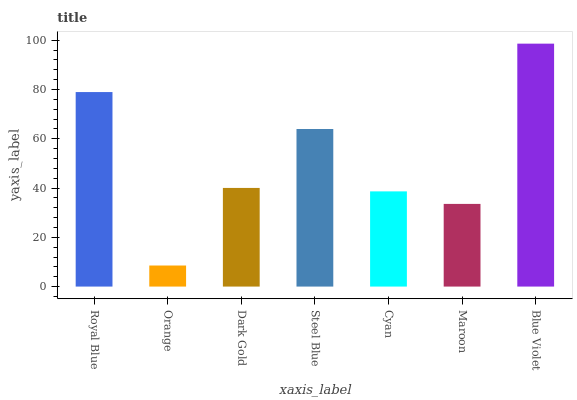Is Orange the minimum?
Answer yes or no. Yes. Is Blue Violet the maximum?
Answer yes or no. Yes. Is Dark Gold the minimum?
Answer yes or no. No. Is Dark Gold the maximum?
Answer yes or no. No. Is Dark Gold greater than Orange?
Answer yes or no. Yes. Is Orange less than Dark Gold?
Answer yes or no. Yes. Is Orange greater than Dark Gold?
Answer yes or no. No. Is Dark Gold less than Orange?
Answer yes or no. No. Is Dark Gold the high median?
Answer yes or no. Yes. Is Dark Gold the low median?
Answer yes or no. Yes. Is Orange the high median?
Answer yes or no. No. Is Steel Blue the low median?
Answer yes or no. No. 